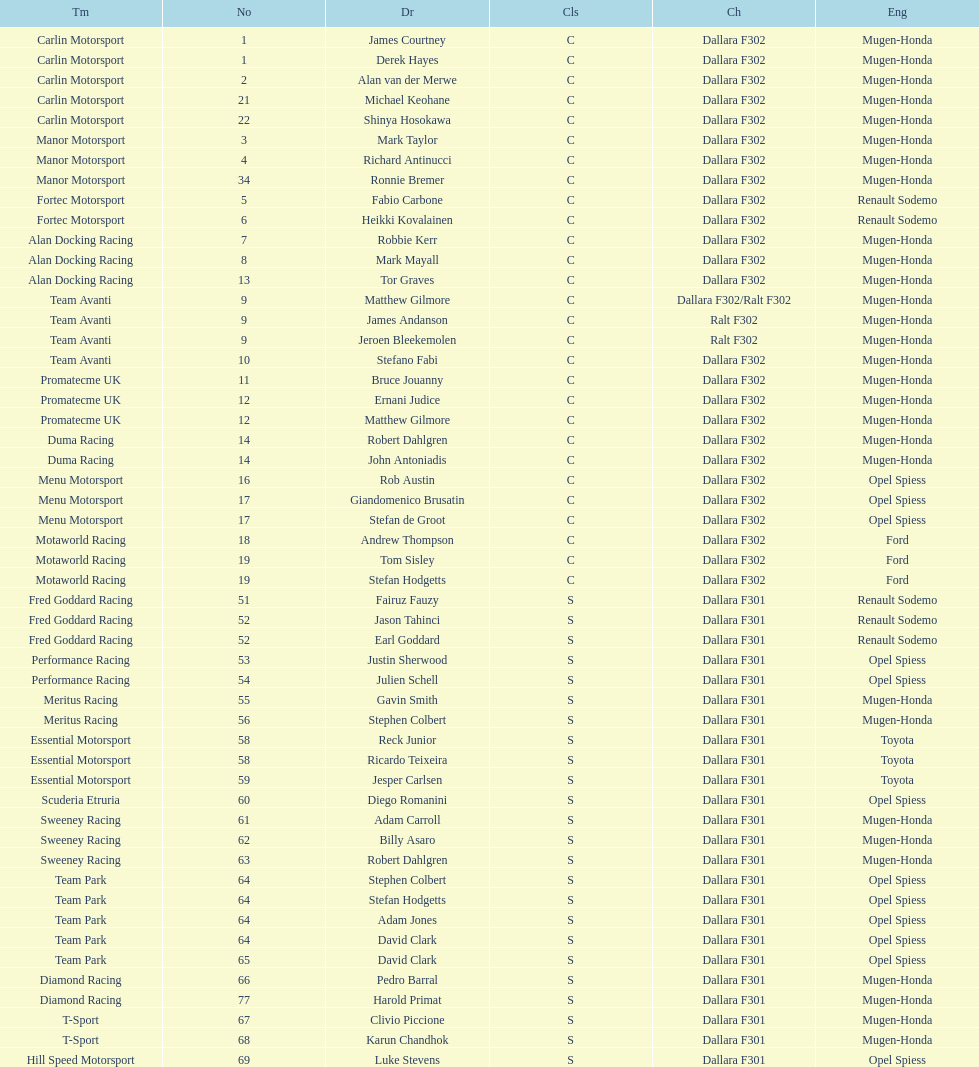Can you give me this table as a dict? {'header': ['Tm', 'No', 'Dr', 'Cls', 'Ch', 'Eng'], 'rows': [['Carlin Motorsport', '1', 'James Courtney', 'C', 'Dallara F302', 'Mugen-Honda'], ['Carlin Motorsport', '1', 'Derek Hayes', 'C', 'Dallara F302', 'Mugen-Honda'], ['Carlin Motorsport', '2', 'Alan van der Merwe', 'C', 'Dallara F302', 'Mugen-Honda'], ['Carlin Motorsport', '21', 'Michael Keohane', 'C', 'Dallara F302', 'Mugen-Honda'], ['Carlin Motorsport', '22', 'Shinya Hosokawa', 'C', 'Dallara F302', 'Mugen-Honda'], ['Manor Motorsport', '3', 'Mark Taylor', 'C', 'Dallara F302', 'Mugen-Honda'], ['Manor Motorsport', '4', 'Richard Antinucci', 'C', 'Dallara F302', 'Mugen-Honda'], ['Manor Motorsport', '34', 'Ronnie Bremer', 'C', 'Dallara F302', 'Mugen-Honda'], ['Fortec Motorsport', '5', 'Fabio Carbone', 'C', 'Dallara F302', 'Renault Sodemo'], ['Fortec Motorsport', '6', 'Heikki Kovalainen', 'C', 'Dallara F302', 'Renault Sodemo'], ['Alan Docking Racing', '7', 'Robbie Kerr', 'C', 'Dallara F302', 'Mugen-Honda'], ['Alan Docking Racing', '8', 'Mark Mayall', 'C', 'Dallara F302', 'Mugen-Honda'], ['Alan Docking Racing', '13', 'Tor Graves', 'C', 'Dallara F302', 'Mugen-Honda'], ['Team Avanti', '9', 'Matthew Gilmore', 'C', 'Dallara F302/Ralt F302', 'Mugen-Honda'], ['Team Avanti', '9', 'James Andanson', 'C', 'Ralt F302', 'Mugen-Honda'], ['Team Avanti', '9', 'Jeroen Bleekemolen', 'C', 'Ralt F302', 'Mugen-Honda'], ['Team Avanti', '10', 'Stefano Fabi', 'C', 'Dallara F302', 'Mugen-Honda'], ['Promatecme UK', '11', 'Bruce Jouanny', 'C', 'Dallara F302', 'Mugen-Honda'], ['Promatecme UK', '12', 'Ernani Judice', 'C', 'Dallara F302', 'Mugen-Honda'], ['Promatecme UK', '12', 'Matthew Gilmore', 'C', 'Dallara F302', 'Mugen-Honda'], ['Duma Racing', '14', 'Robert Dahlgren', 'C', 'Dallara F302', 'Mugen-Honda'], ['Duma Racing', '14', 'John Antoniadis', 'C', 'Dallara F302', 'Mugen-Honda'], ['Menu Motorsport', '16', 'Rob Austin', 'C', 'Dallara F302', 'Opel Spiess'], ['Menu Motorsport', '17', 'Giandomenico Brusatin', 'C', 'Dallara F302', 'Opel Spiess'], ['Menu Motorsport', '17', 'Stefan de Groot', 'C', 'Dallara F302', 'Opel Spiess'], ['Motaworld Racing', '18', 'Andrew Thompson', 'C', 'Dallara F302', 'Ford'], ['Motaworld Racing', '19', 'Tom Sisley', 'C', 'Dallara F302', 'Ford'], ['Motaworld Racing', '19', 'Stefan Hodgetts', 'C', 'Dallara F302', 'Ford'], ['Fred Goddard Racing', '51', 'Fairuz Fauzy', 'S', 'Dallara F301', 'Renault Sodemo'], ['Fred Goddard Racing', '52', 'Jason Tahinci', 'S', 'Dallara F301', 'Renault Sodemo'], ['Fred Goddard Racing', '52', 'Earl Goddard', 'S', 'Dallara F301', 'Renault Sodemo'], ['Performance Racing', '53', 'Justin Sherwood', 'S', 'Dallara F301', 'Opel Spiess'], ['Performance Racing', '54', 'Julien Schell', 'S', 'Dallara F301', 'Opel Spiess'], ['Meritus Racing', '55', 'Gavin Smith', 'S', 'Dallara F301', 'Mugen-Honda'], ['Meritus Racing', '56', 'Stephen Colbert', 'S', 'Dallara F301', 'Mugen-Honda'], ['Essential Motorsport', '58', 'Reck Junior', 'S', 'Dallara F301', 'Toyota'], ['Essential Motorsport', '58', 'Ricardo Teixeira', 'S', 'Dallara F301', 'Toyota'], ['Essential Motorsport', '59', 'Jesper Carlsen', 'S', 'Dallara F301', 'Toyota'], ['Scuderia Etruria', '60', 'Diego Romanini', 'S', 'Dallara F301', 'Opel Spiess'], ['Sweeney Racing', '61', 'Adam Carroll', 'S', 'Dallara F301', 'Mugen-Honda'], ['Sweeney Racing', '62', 'Billy Asaro', 'S', 'Dallara F301', 'Mugen-Honda'], ['Sweeney Racing', '63', 'Robert Dahlgren', 'S', 'Dallara F301', 'Mugen-Honda'], ['Team Park', '64', 'Stephen Colbert', 'S', 'Dallara F301', 'Opel Spiess'], ['Team Park', '64', 'Stefan Hodgetts', 'S', 'Dallara F301', 'Opel Spiess'], ['Team Park', '64', 'Adam Jones', 'S', 'Dallara F301', 'Opel Spiess'], ['Team Park', '64', 'David Clark', 'S', 'Dallara F301', 'Opel Spiess'], ['Team Park', '65', 'David Clark', 'S', 'Dallara F301', 'Opel Spiess'], ['Diamond Racing', '66', 'Pedro Barral', 'S', 'Dallara F301', 'Mugen-Honda'], ['Diamond Racing', '77', 'Harold Primat', 'S', 'Dallara F301', 'Mugen-Honda'], ['T-Sport', '67', 'Clivio Piccione', 'S', 'Dallara F301', 'Mugen-Honda'], ['T-Sport', '68', 'Karun Chandhok', 'S', 'Dallara F301', 'Mugen-Honda'], ['Hill Speed Motorsport', '69', 'Luke Stevens', 'S', 'Dallara F301', 'Opel Spiess']]} What is the quantity of teams with drivers all originating from the same nation? 4. 